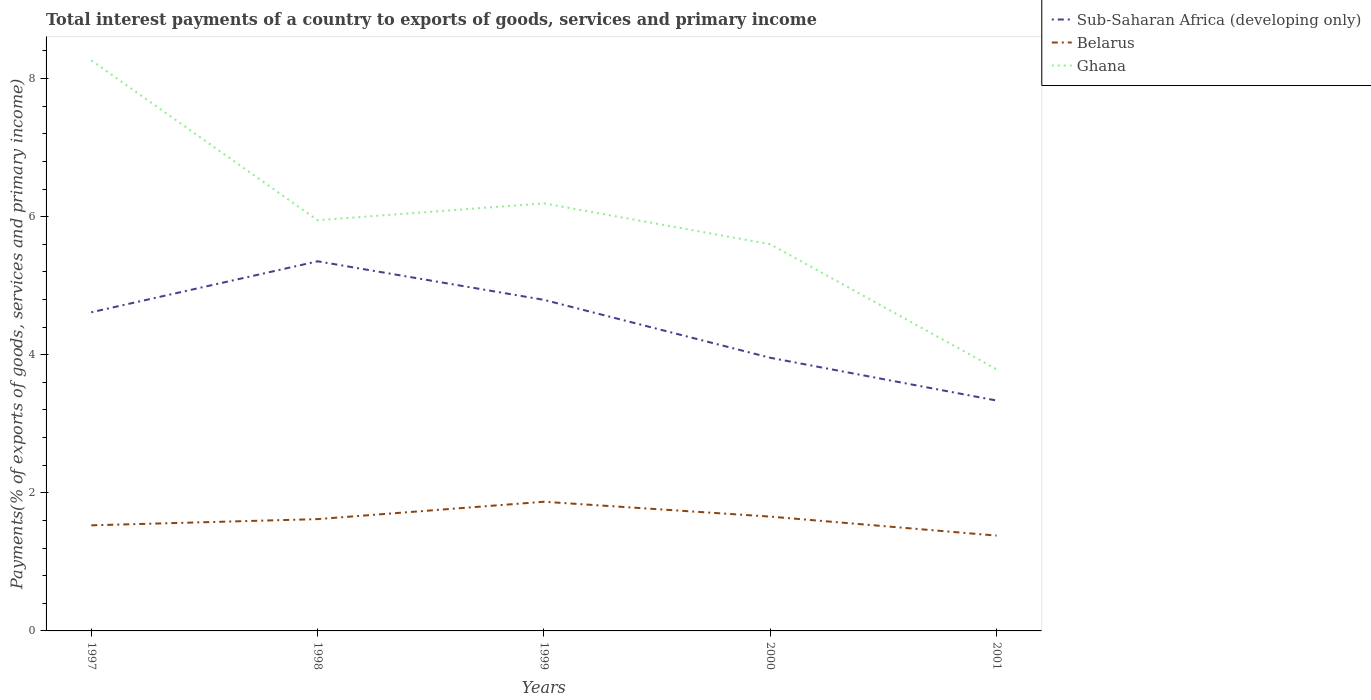How many different coloured lines are there?
Your answer should be very brief. 3. Is the number of lines equal to the number of legend labels?
Give a very brief answer. Yes. Across all years, what is the maximum total interest payments in Ghana?
Keep it short and to the point. 3.79. What is the total total interest payments in Belarus in the graph?
Keep it short and to the point. -0.04. What is the difference between the highest and the second highest total interest payments in Ghana?
Offer a very short reply. 4.47. What is the difference between the highest and the lowest total interest payments in Ghana?
Offer a terse response. 2. Is the total interest payments in Ghana strictly greater than the total interest payments in Sub-Saharan Africa (developing only) over the years?
Offer a very short reply. No. How many lines are there?
Ensure brevity in your answer.  3. How many years are there in the graph?
Your answer should be very brief. 5. What is the difference between two consecutive major ticks on the Y-axis?
Your response must be concise. 2. How are the legend labels stacked?
Your answer should be very brief. Vertical. What is the title of the graph?
Keep it short and to the point. Total interest payments of a country to exports of goods, services and primary income. What is the label or title of the Y-axis?
Provide a succinct answer. Payments(% of exports of goods, services and primary income). What is the Payments(% of exports of goods, services and primary income) of Sub-Saharan Africa (developing only) in 1997?
Provide a short and direct response. 4.62. What is the Payments(% of exports of goods, services and primary income) of Belarus in 1997?
Provide a succinct answer. 1.53. What is the Payments(% of exports of goods, services and primary income) in Ghana in 1997?
Give a very brief answer. 8.26. What is the Payments(% of exports of goods, services and primary income) of Sub-Saharan Africa (developing only) in 1998?
Make the answer very short. 5.35. What is the Payments(% of exports of goods, services and primary income) of Belarus in 1998?
Provide a short and direct response. 1.62. What is the Payments(% of exports of goods, services and primary income) in Ghana in 1998?
Ensure brevity in your answer.  5.95. What is the Payments(% of exports of goods, services and primary income) of Sub-Saharan Africa (developing only) in 1999?
Ensure brevity in your answer.  4.8. What is the Payments(% of exports of goods, services and primary income) of Belarus in 1999?
Keep it short and to the point. 1.87. What is the Payments(% of exports of goods, services and primary income) in Ghana in 1999?
Ensure brevity in your answer.  6.19. What is the Payments(% of exports of goods, services and primary income) of Sub-Saharan Africa (developing only) in 2000?
Your answer should be compact. 3.96. What is the Payments(% of exports of goods, services and primary income) of Belarus in 2000?
Make the answer very short. 1.66. What is the Payments(% of exports of goods, services and primary income) in Ghana in 2000?
Ensure brevity in your answer.  5.6. What is the Payments(% of exports of goods, services and primary income) in Sub-Saharan Africa (developing only) in 2001?
Provide a succinct answer. 3.34. What is the Payments(% of exports of goods, services and primary income) of Belarus in 2001?
Your answer should be very brief. 1.38. What is the Payments(% of exports of goods, services and primary income) in Ghana in 2001?
Ensure brevity in your answer.  3.79. Across all years, what is the maximum Payments(% of exports of goods, services and primary income) of Sub-Saharan Africa (developing only)?
Offer a very short reply. 5.35. Across all years, what is the maximum Payments(% of exports of goods, services and primary income) of Belarus?
Ensure brevity in your answer.  1.87. Across all years, what is the maximum Payments(% of exports of goods, services and primary income) of Ghana?
Your response must be concise. 8.26. Across all years, what is the minimum Payments(% of exports of goods, services and primary income) of Sub-Saharan Africa (developing only)?
Offer a terse response. 3.34. Across all years, what is the minimum Payments(% of exports of goods, services and primary income) of Belarus?
Provide a short and direct response. 1.38. Across all years, what is the minimum Payments(% of exports of goods, services and primary income) of Ghana?
Offer a very short reply. 3.79. What is the total Payments(% of exports of goods, services and primary income) in Sub-Saharan Africa (developing only) in the graph?
Give a very brief answer. 22.06. What is the total Payments(% of exports of goods, services and primary income) in Belarus in the graph?
Give a very brief answer. 8.06. What is the total Payments(% of exports of goods, services and primary income) in Ghana in the graph?
Provide a succinct answer. 29.8. What is the difference between the Payments(% of exports of goods, services and primary income) of Sub-Saharan Africa (developing only) in 1997 and that in 1998?
Provide a short and direct response. -0.74. What is the difference between the Payments(% of exports of goods, services and primary income) in Belarus in 1997 and that in 1998?
Make the answer very short. -0.09. What is the difference between the Payments(% of exports of goods, services and primary income) in Ghana in 1997 and that in 1998?
Provide a short and direct response. 2.32. What is the difference between the Payments(% of exports of goods, services and primary income) of Sub-Saharan Africa (developing only) in 1997 and that in 1999?
Provide a short and direct response. -0.18. What is the difference between the Payments(% of exports of goods, services and primary income) of Belarus in 1997 and that in 1999?
Your response must be concise. -0.34. What is the difference between the Payments(% of exports of goods, services and primary income) of Ghana in 1997 and that in 1999?
Your response must be concise. 2.07. What is the difference between the Payments(% of exports of goods, services and primary income) in Sub-Saharan Africa (developing only) in 1997 and that in 2000?
Keep it short and to the point. 0.66. What is the difference between the Payments(% of exports of goods, services and primary income) of Belarus in 1997 and that in 2000?
Offer a terse response. -0.13. What is the difference between the Payments(% of exports of goods, services and primary income) in Ghana in 1997 and that in 2000?
Your answer should be compact. 2.66. What is the difference between the Payments(% of exports of goods, services and primary income) in Sub-Saharan Africa (developing only) in 1997 and that in 2001?
Give a very brief answer. 1.28. What is the difference between the Payments(% of exports of goods, services and primary income) in Belarus in 1997 and that in 2001?
Offer a very short reply. 0.15. What is the difference between the Payments(% of exports of goods, services and primary income) in Ghana in 1997 and that in 2001?
Make the answer very short. 4.47. What is the difference between the Payments(% of exports of goods, services and primary income) of Sub-Saharan Africa (developing only) in 1998 and that in 1999?
Provide a short and direct response. 0.56. What is the difference between the Payments(% of exports of goods, services and primary income) in Belarus in 1998 and that in 1999?
Your answer should be compact. -0.25. What is the difference between the Payments(% of exports of goods, services and primary income) of Ghana in 1998 and that in 1999?
Give a very brief answer. -0.24. What is the difference between the Payments(% of exports of goods, services and primary income) in Sub-Saharan Africa (developing only) in 1998 and that in 2000?
Your response must be concise. 1.4. What is the difference between the Payments(% of exports of goods, services and primary income) of Belarus in 1998 and that in 2000?
Offer a very short reply. -0.04. What is the difference between the Payments(% of exports of goods, services and primary income) in Ghana in 1998 and that in 2000?
Your answer should be very brief. 0.35. What is the difference between the Payments(% of exports of goods, services and primary income) in Sub-Saharan Africa (developing only) in 1998 and that in 2001?
Make the answer very short. 2.02. What is the difference between the Payments(% of exports of goods, services and primary income) of Belarus in 1998 and that in 2001?
Ensure brevity in your answer.  0.24. What is the difference between the Payments(% of exports of goods, services and primary income) of Ghana in 1998 and that in 2001?
Offer a very short reply. 2.16. What is the difference between the Payments(% of exports of goods, services and primary income) of Sub-Saharan Africa (developing only) in 1999 and that in 2000?
Offer a terse response. 0.84. What is the difference between the Payments(% of exports of goods, services and primary income) of Belarus in 1999 and that in 2000?
Give a very brief answer. 0.22. What is the difference between the Payments(% of exports of goods, services and primary income) in Ghana in 1999 and that in 2000?
Your answer should be very brief. 0.59. What is the difference between the Payments(% of exports of goods, services and primary income) of Sub-Saharan Africa (developing only) in 1999 and that in 2001?
Offer a very short reply. 1.46. What is the difference between the Payments(% of exports of goods, services and primary income) in Belarus in 1999 and that in 2001?
Give a very brief answer. 0.49. What is the difference between the Payments(% of exports of goods, services and primary income) of Ghana in 1999 and that in 2001?
Offer a very short reply. 2.4. What is the difference between the Payments(% of exports of goods, services and primary income) of Sub-Saharan Africa (developing only) in 2000 and that in 2001?
Provide a short and direct response. 0.62. What is the difference between the Payments(% of exports of goods, services and primary income) in Belarus in 2000 and that in 2001?
Give a very brief answer. 0.28. What is the difference between the Payments(% of exports of goods, services and primary income) in Ghana in 2000 and that in 2001?
Ensure brevity in your answer.  1.81. What is the difference between the Payments(% of exports of goods, services and primary income) of Sub-Saharan Africa (developing only) in 1997 and the Payments(% of exports of goods, services and primary income) of Belarus in 1998?
Your answer should be compact. 3. What is the difference between the Payments(% of exports of goods, services and primary income) in Sub-Saharan Africa (developing only) in 1997 and the Payments(% of exports of goods, services and primary income) in Ghana in 1998?
Provide a succinct answer. -1.33. What is the difference between the Payments(% of exports of goods, services and primary income) of Belarus in 1997 and the Payments(% of exports of goods, services and primary income) of Ghana in 1998?
Offer a terse response. -4.42. What is the difference between the Payments(% of exports of goods, services and primary income) of Sub-Saharan Africa (developing only) in 1997 and the Payments(% of exports of goods, services and primary income) of Belarus in 1999?
Give a very brief answer. 2.74. What is the difference between the Payments(% of exports of goods, services and primary income) of Sub-Saharan Africa (developing only) in 1997 and the Payments(% of exports of goods, services and primary income) of Ghana in 1999?
Give a very brief answer. -1.58. What is the difference between the Payments(% of exports of goods, services and primary income) in Belarus in 1997 and the Payments(% of exports of goods, services and primary income) in Ghana in 1999?
Offer a terse response. -4.66. What is the difference between the Payments(% of exports of goods, services and primary income) of Sub-Saharan Africa (developing only) in 1997 and the Payments(% of exports of goods, services and primary income) of Belarus in 2000?
Offer a terse response. 2.96. What is the difference between the Payments(% of exports of goods, services and primary income) of Sub-Saharan Africa (developing only) in 1997 and the Payments(% of exports of goods, services and primary income) of Ghana in 2000?
Provide a succinct answer. -0.99. What is the difference between the Payments(% of exports of goods, services and primary income) in Belarus in 1997 and the Payments(% of exports of goods, services and primary income) in Ghana in 2000?
Provide a succinct answer. -4.07. What is the difference between the Payments(% of exports of goods, services and primary income) in Sub-Saharan Africa (developing only) in 1997 and the Payments(% of exports of goods, services and primary income) in Belarus in 2001?
Ensure brevity in your answer.  3.23. What is the difference between the Payments(% of exports of goods, services and primary income) in Sub-Saharan Africa (developing only) in 1997 and the Payments(% of exports of goods, services and primary income) in Ghana in 2001?
Your response must be concise. 0.83. What is the difference between the Payments(% of exports of goods, services and primary income) of Belarus in 1997 and the Payments(% of exports of goods, services and primary income) of Ghana in 2001?
Offer a very short reply. -2.26. What is the difference between the Payments(% of exports of goods, services and primary income) in Sub-Saharan Africa (developing only) in 1998 and the Payments(% of exports of goods, services and primary income) in Belarus in 1999?
Your answer should be very brief. 3.48. What is the difference between the Payments(% of exports of goods, services and primary income) of Sub-Saharan Africa (developing only) in 1998 and the Payments(% of exports of goods, services and primary income) of Ghana in 1999?
Your response must be concise. -0.84. What is the difference between the Payments(% of exports of goods, services and primary income) in Belarus in 1998 and the Payments(% of exports of goods, services and primary income) in Ghana in 1999?
Your answer should be very brief. -4.57. What is the difference between the Payments(% of exports of goods, services and primary income) of Sub-Saharan Africa (developing only) in 1998 and the Payments(% of exports of goods, services and primary income) of Belarus in 2000?
Provide a succinct answer. 3.7. What is the difference between the Payments(% of exports of goods, services and primary income) in Sub-Saharan Africa (developing only) in 1998 and the Payments(% of exports of goods, services and primary income) in Ghana in 2000?
Offer a terse response. -0.25. What is the difference between the Payments(% of exports of goods, services and primary income) of Belarus in 1998 and the Payments(% of exports of goods, services and primary income) of Ghana in 2000?
Provide a succinct answer. -3.98. What is the difference between the Payments(% of exports of goods, services and primary income) of Sub-Saharan Africa (developing only) in 1998 and the Payments(% of exports of goods, services and primary income) of Belarus in 2001?
Your answer should be compact. 3.97. What is the difference between the Payments(% of exports of goods, services and primary income) of Sub-Saharan Africa (developing only) in 1998 and the Payments(% of exports of goods, services and primary income) of Ghana in 2001?
Offer a terse response. 1.56. What is the difference between the Payments(% of exports of goods, services and primary income) of Belarus in 1998 and the Payments(% of exports of goods, services and primary income) of Ghana in 2001?
Your answer should be compact. -2.17. What is the difference between the Payments(% of exports of goods, services and primary income) of Sub-Saharan Africa (developing only) in 1999 and the Payments(% of exports of goods, services and primary income) of Belarus in 2000?
Offer a very short reply. 3.14. What is the difference between the Payments(% of exports of goods, services and primary income) in Sub-Saharan Africa (developing only) in 1999 and the Payments(% of exports of goods, services and primary income) in Ghana in 2000?
Provide a short and direct response. -0.81. What is the difference between the Payments(% of exports of goods, services and primary income) in Belarus in 1999 and the Payments(% of exports of goods, services and primary income) in Ghana in 2000?
Provide a succinct answer. -3.73. What is the difference between the Payments(% of exports of goods, services and primary income) of Sub-Saharan Africa (developing only) in 1999 and the Payments(% of exports of goods, services and primary income) of Belarus in 2001?
Offer a very short reply. 3.41. What is the difference between the Payments(% of exports of goods, services and primary income) of Belarus in 1999 and the Payments(% of exports of goods, services and primary income) of Ghana in 2001?
Your answer should be compact. -1.92. What is the difference between the Payments(% of exports of goods, services and primary income) in Sub-Saharan Africa (developing only) in 2000 and the Payments(% of exports of goods, services and primary income) in Belarus in 2001?
Your answer should be very brief. 2.58. What is the difference between the Payments(% of exports of goods, services and primary income) in Sub-Saharan Africa (developing only) in 2000 and the Payments(% of exports of goods, services and primary income) in Ghana in 2001?
Provide a short and direct response. 0.17. What is the difference between the Payments(% of exports of goods, services and primary income) of Belarus in 2000 and the Payments(% of exports of goods, services and primary income) of Ghana in 2001?
Make the answer very short. -2.13. What is the average Payments(% of exports of goods, services and primary income) of Sub-Saharan Africa (developing only) per year?
Provide a succinct answer. 4.41. What is the average Payments(% of exports of goods, services and primary income) in Belarus per year?
Offer a terse response. 1.61. What is the average Payments(% of exports of goods, services and primary income) of Ghana per year?
Your response must be concise. 5.96. In the year 1997, what is the difference between the Payments(% of exports of goods, services and primary income) of Sub-Saharan Africa (developing only) and Payments(% of exports of goods, services and primary income) of Belarus?
Your answer should be very brief. 3.09. In the year 1997, what is the difference between the Payments(% of exports of goods, services and primary income) in Sub-Saharan Africa (developing only) and Payments(% of exports of goods, services and primary income) in Ghana?
Make the answer very short. -3.65. In the year 1997, what is the difference between the Payments(% of exports of goods, services and primary income) in Belarus and Payments(% of exports of goods, services and primary income) in Ghana?
Provide a short and direct response. -6.74. In the year 1998, what is the difference between the Payments(% of exports of goods, services and primary income) in Sub-Saharan Africa (developing only) and Payments(% of exports of goods, services and primary income) in Belarus?
Provide a short and direct response. 3.73. In the year 1998, what is the difference between the Payments(% of exports of goods, services and primary income) of Sub-Saharan Africa (developing only) and Payments(% of exports of goods, services and primary income) of Ghana?
Your response must be concise. -0.59. In the year 1998, what is the difference between the Payments(% of exports of goods, services and primary income) of Belarus and Payments(% of exports of goods, services and primary income) of Ghana?
Keep it short and to the point. -4.33. In the year 1999, what is the difference between the Payments(% of exports of goods, services and primary income) in Sub-Saharan Africa (developing only) and Payments(% of exports of goods, services and primary income) in Belarus?
Give a very brief answer. 2.92. In the year 1999, what is the difference between the Payments(% of exports of goods, services and primary income) in Sub-Saharan Africa (developing only) and Payments(% of exports of goods, services and primary income) in Ghana?
Make the answer very short. -1.4. In the year 1999, what is the difference between the Payments(% of exports of goods, services and primary income) of Belarus and Payments(% of exports of goods, services and primary income) of Ghana?
Offer a very short reply. -4.32. In the year 2000, what is the difference between the Payments(% of exports of goods, services and primary income) of Sub-Saharan Africa (developing only) and Payments(% of exports of goods, services and primary income) of Belarus?
Your answer should be very brief. 2.3. In the year 2000, what is the difference between the Payments(% of exports of goods, services and primary income) in Sub-Saharan Africa (developing only) and Payments(% of exports of goods, services and primary income) in Ghana?
Keep it short and to the point. -1.64. In the year 2000, what is the difference between the Payments(% of exports of goods, services and primary income) in Belarus and Payments(% of exports of goods, services and primary income) in Ghana?
Give a very brief answer. -3.95. In the year 2001, what is the difference between the Payments(% of exports of goods, services and primary income) of Sub-Saharan Africa (developing only) and Payments(% of exports of goods, services and primary income) of Belarus?
Your answer should be compact. 1.96. In the year 2001, what is the difference between the Payments(% of exports of goods, services and primary income) in Sub-Saharan Africa (developing only) and Payments(% of exports of goods, services and primary income) in Ghana?
Provide a short and direct response. -0.45. In the year 2001, what is the difference between the Payments(% of exports of goods, services and primary income) in Belarus and Payments(% of exports of goods, services and primary income) in Ghana?
Provide a succinct answer. -2.41. What is the ratio of the Payments(% of exports of goods, services and primary income) of Sub-Saharan Africa (developing only) in 1997 to that in 1998?
Provide a succinct answer. 0.86. What is the ratio of the Payments(% of exports of goods, services and primary income) in Ghana in 1997 to that in 1998?
Offer a terse response. 1.39. What is the ratio of the Payments(% of exports of goods, services and primary income) in Sub-Saharan Africa (developing only) in 1997 to that in 1999?
Keep it short and to the point. 0.96. What is the ratio of the Payments(% of exports of goods, services and primary income) in Belarus in 1997 to that in 1999?
Provide a short and direct response. 0.82. What is the ratio of the Payments(% of exports of goods, services and primary income) of Ghana in 1997 to that in 1999?
Keep it short and to the point. 1.33. What is the ratio of the Payments(% of exports of goods, services and primary income) of Sub-Saharan Africa (developing only) in 1997 to that in 2000?
Provide a succinct answer. 1.17. What is the ratio of the Payments(% of exports of goods, services and primary income) in Belarus in 1997 to that in 2000?
Your response must be concise. 0.92. What is the ratio of the Payments(% of exports of goods, services and primary income) in Ghana in 1997 to that in 2000?
Provide a succinct answer. 1.48. What is the ratio of the Payments(% of exports of goods, services and primary income) in Sub-Saharan Africa (developing only) in 1997 to that in 2001?
Keep it short and to the point. 1.38. What is the ratio of the Payments(% of exports of goods, services and primary income) in Belarus in 1997 to that in 2001?
Offer a terse response. 1.11. What is the ratio of the Payments(% of exports of goods, services and primary income) of Ghana in 1997 to that in 2001?
Ensure brevity in your answer.  2.18. What is the ratio of the Payments(% of exports of goods, services and primary income) of Sub-Saharan Africa (developing only) in 1998 to that in 1999?
Your answer should be very brief. 1.12. What is the ratio of the Payments(% of exports of goods, services and primary income) of Belarus in 1998 to that in 1999?
Give a very brief answer. 0.87. What is the ratio of the Payments(% of exports of goods, services and primary income) in Ghana in 1998 to that in 1999?
Offer a terse response. 0.96. What is the ratio of the Payments(% of exports of goods, services and primary income) of Sub-Saharan Africa (developing only) in 1998 to that in 2000?
Provide a short and direct response. 1.35. What is the ratio of the Payments(% of exports of goods, services and primary income) in Belarus in 1998 to that in 2000?
Give a very brief answer. 0.98. What is the ratio of the Payments(% of exports of goods, services and primary income) in Ghana in 1998 to that in 2000?
Make the answer very short. 1.06. What is the ratio of the Payments(% of exports of goods, services and primary income) in Sub-Saharan Africa (developing only) in 1998 to that in 2001?
Make the answer very short. 1.6. What is the ratio of the Payments(% of exports of goods, services and primary income) in Belarus in 1998 to that in 2001?
Ensure brevity in your answer.  1.17. What is the ratio of the Payments(% of exports of goods, services and primary income) in Ghana in 1998 to that in 2001?
Make the answer very short. 1.57. What is the ratio of the Payments(% of exports of goods, services and primary income) of Sub-Saharan Africa (developing only) in 1999 to that in 2000?
Offer a very short reply. 1.21. What is the ratio of the Payments(% of exports of goods, services and primary income) in Belarus in 1999 to that in 2000?
Give a very brief answer. 1.13. What is the ratio of the Payments(% of exports of goods, services and primary income) of Ghana in 1999 to that in 2000?
Provide a succinct answer. 1.11. What is the ratio of the Payments(% of exports of goods, services and primary income) in Sub-Saharan Africa (developing only) in 1999 to that in 2001?
Give a very brief answer. 1.44. What is the ratio of the Payments(% of exports of goods, services and primary income) in Belarus in 1999 to that in 2001?
Keep it short and to the point. 1.36. What is the ratio of the Payments(% of exports of goods, services and primary income) of Ghana in 1999 to that in 2001?
Your response must be concise. 1.63. What is the ratio of the Payments(% of exports of goods, services and primary income) in Sub-Saharan Africa (developing only) in 2000 to that in 2001?
Ensure brevity in your answer.  1.19. What is the ratio of the Payments(% of exports of goods, services and primary income) of Belarus in 2000 to that in 2001?
Ensure brevity in your answer.  1.2. What is the ratio of the Payments(% of exports of goods, services and primary income) of Ghana in 2000 to that in 2001?
Give a very brief answer. 1.48. What is the difference between the highest and the second highest Payments(% of exports of goods, services and primary income) in Sub-Saharan Africa (developing only)?
Your response must be concise. 0.56. What is the difference between the highest and the second highest Payments(% of exports of goods, services and primary income) in Belarus?
Provide a short and direct response. 0.22. What is the difference between the highest and the second highest Payments(% of exports of goods, services and primary income) in Ghana?
Give a very brief answer. 2.07. What is the difference between the highest and the lowest Payments(% of exports of goods, services and primary income) of Sub-Saharan Africa (developing only)?
Your answer should be very brief. 2.02. What is the difference between the highest and the lowest Payments(% of exports of goods, services and primary income) of Belarus?
Offer a very short reply. 0.49. What is the difference between the highest and the lowest Payments(% of exports of goods, services and primary income) in Ghana?
Make the answer very short. 4.47. 